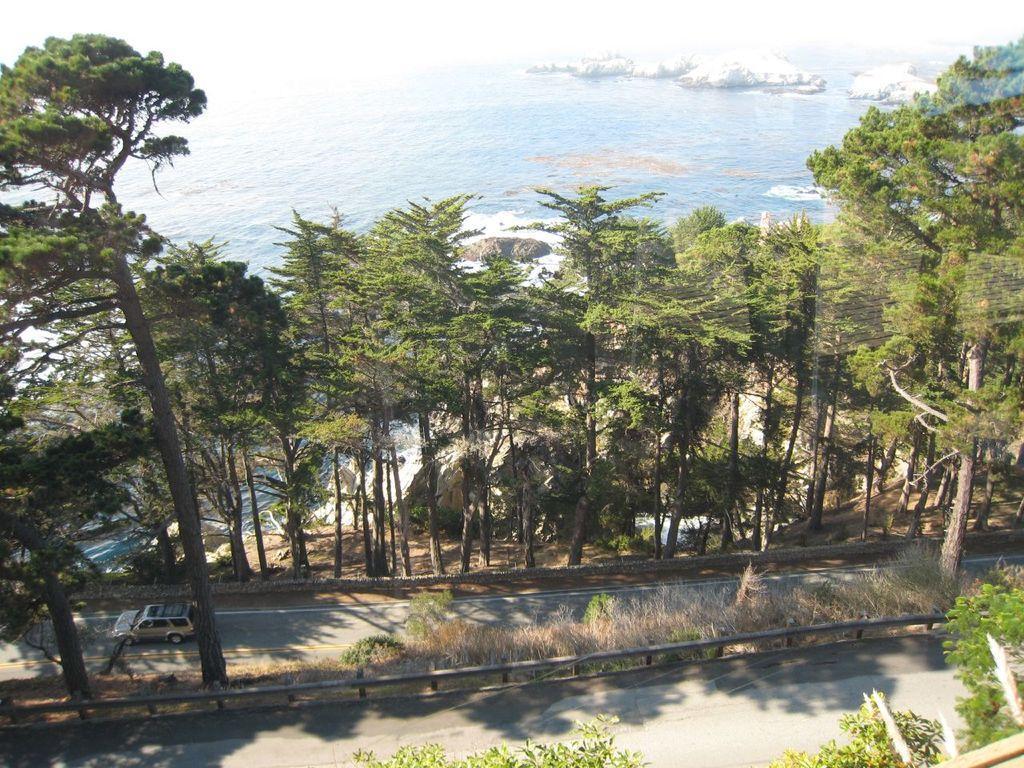In one or two sentences, can you explain what this image depicts? In this image there is a vehicle moving on the road. On the left and right side of the road there are trees, in the middle of the road there is a railing and grass. In the background there is a river. 